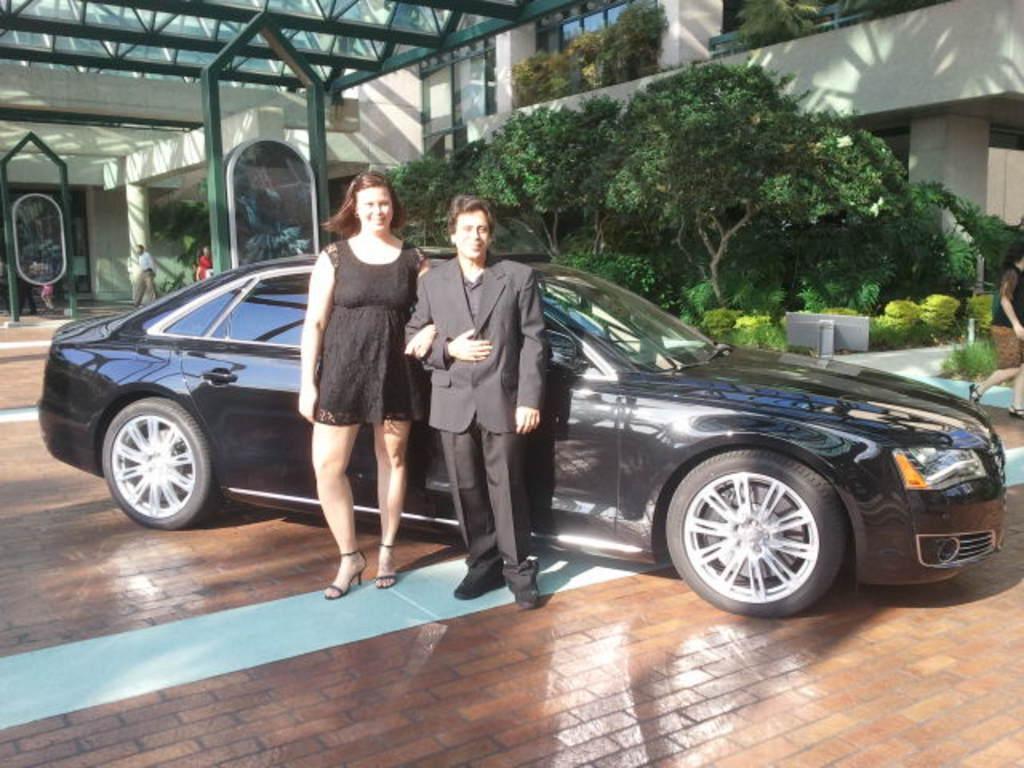Can you describe this image briefly? There is a man and a woman standing besides a car. Here we can see plants, trees, pillars, and few persons. In the background there is a building. 